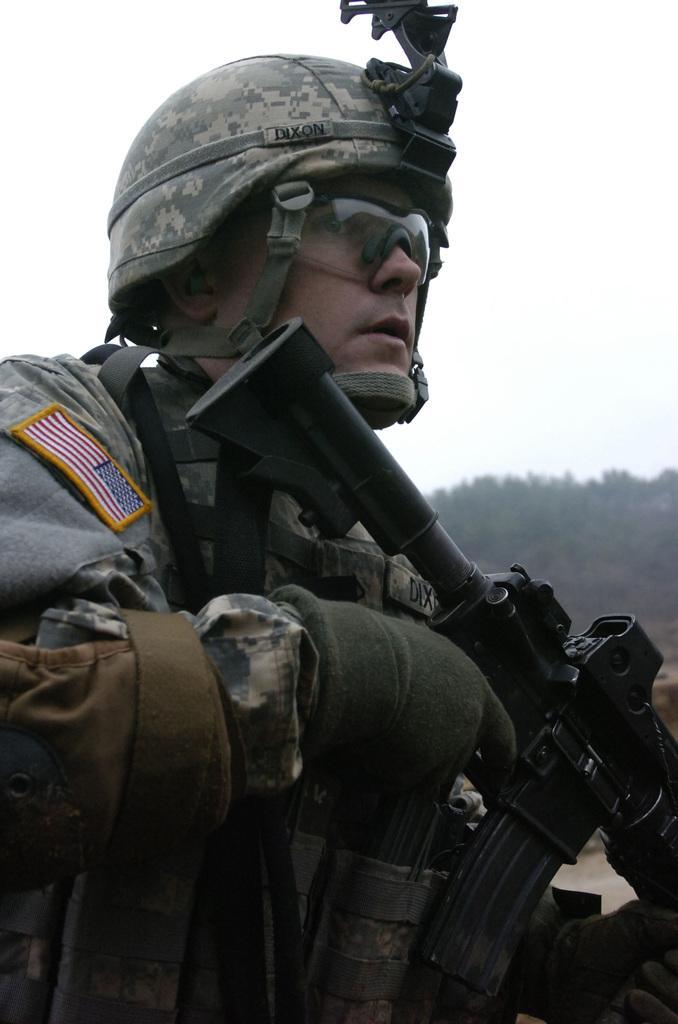How would you summarize this image in a sentence or two? In the image there is a man holding a gun in his hands. He kept goggles and there is a helmet on his head. Behind him there are trees. And also there is sky.  